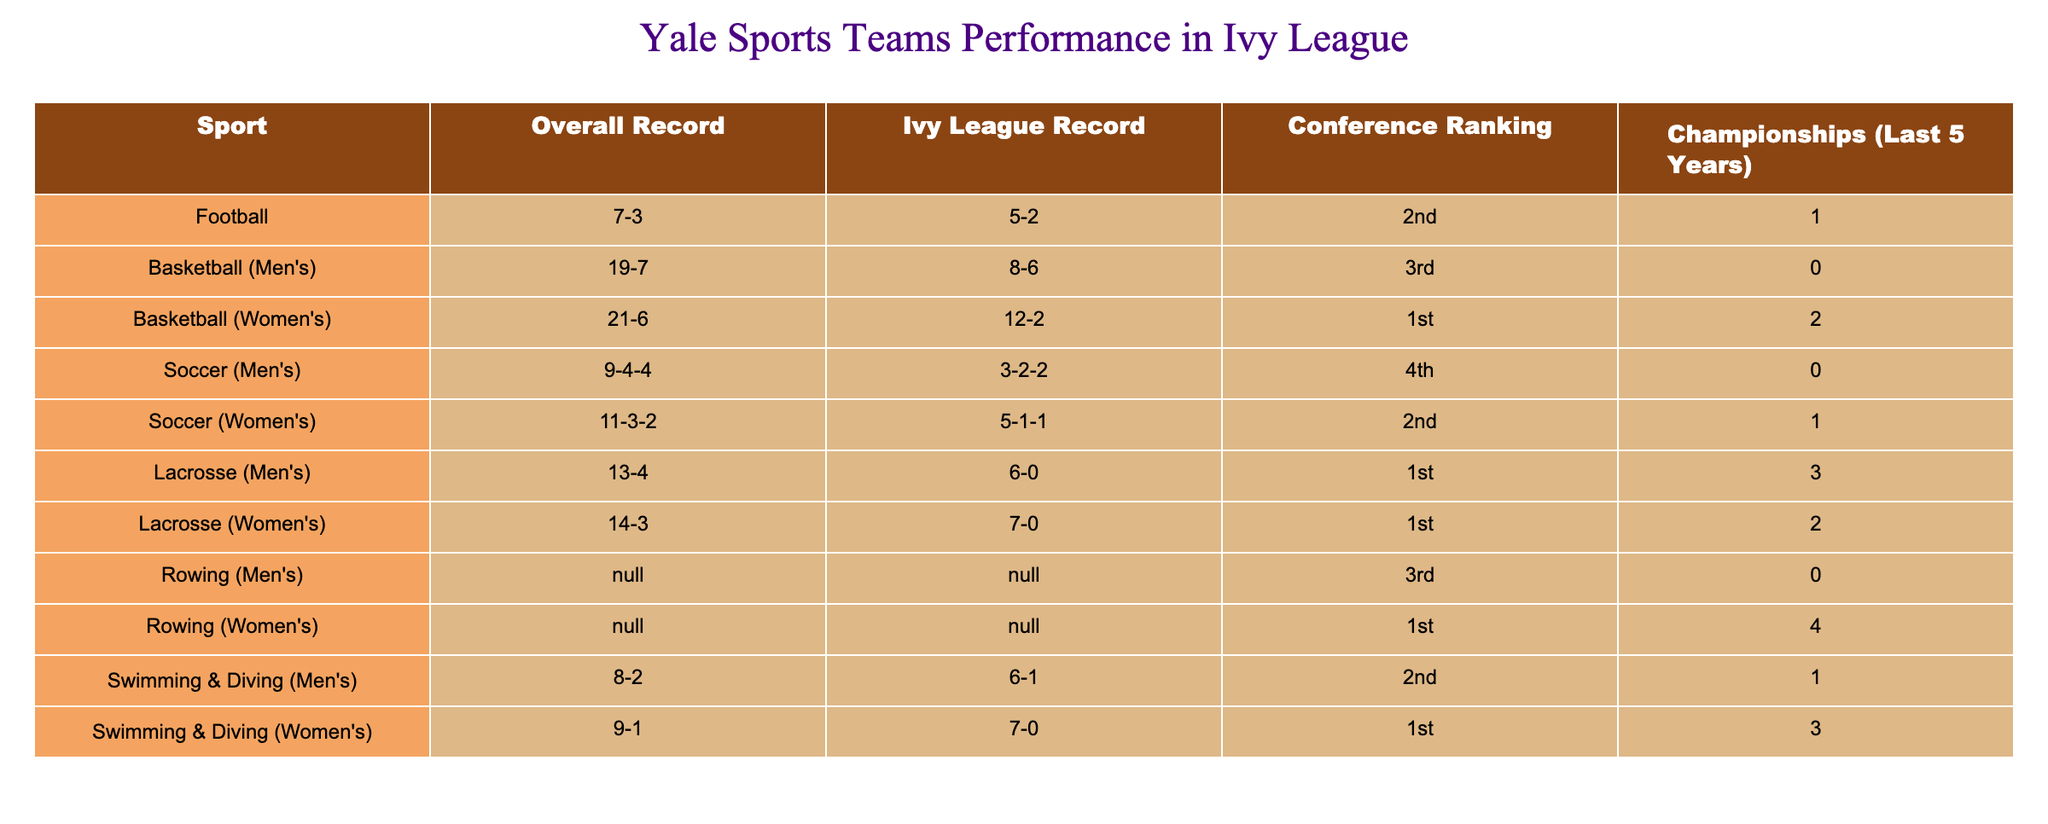What is the overall record of the Yale men's basketball team? The overall record is directly listed in the table under the "Overall Record" column for the men's basketball team. It shows 19-7.
Answer: 19-7 How many Ivy League Championships has the Yale women's lacrosse team won in the last 5 years? The table specifically states that the Yale women's lacrosse team has won 2 championships in the last 5 years, as indicated in the "Championships (Last 5 Years)" column.
Answer: 2 Which Yale team has the best Ivy League record this season? The table presents the Ivy League records for all teams, and the men's lacrosse team has the best record at 6-0. This is determined by comparing the Ivy League records of all teams listed.
Answer: Men's Lacrosse Is the Yale rowing team ranked in the conference? The table shows that both the men's and women's rowing teams have "N/A" for their records, indicating that these teams are not ranked in the conference. Thus, the statement is true.
Answer: Yes What is the total number of championships won by Yale sports teams in the last 5 years? To find the total, we add up the championships won by each team: 1 (Football) + 0 (Men's Basketball) + 2 (Women's Basketball) + 0 (Men's Soccer) + 1 (Women's Soccer) + 3 (Men's Lacrosse) + 2 (Women's Lacrosse) + 0 (Men's Rowing) + 4 (Women's Rowing) + 1 (Men's Swimming & Diving) + 3 (Women's Swimming & Diving) = 18. Therefore, the total number of championships is 18.
Answer: 18 Which Yale sports team has the worst conference ranking? By examining the "Conference Ranking" column, the table indicates that the men's soccer team is ranked 4th, which is the lowest ranking among Yale teams listed in the table.
Answer: Men's Soccer 